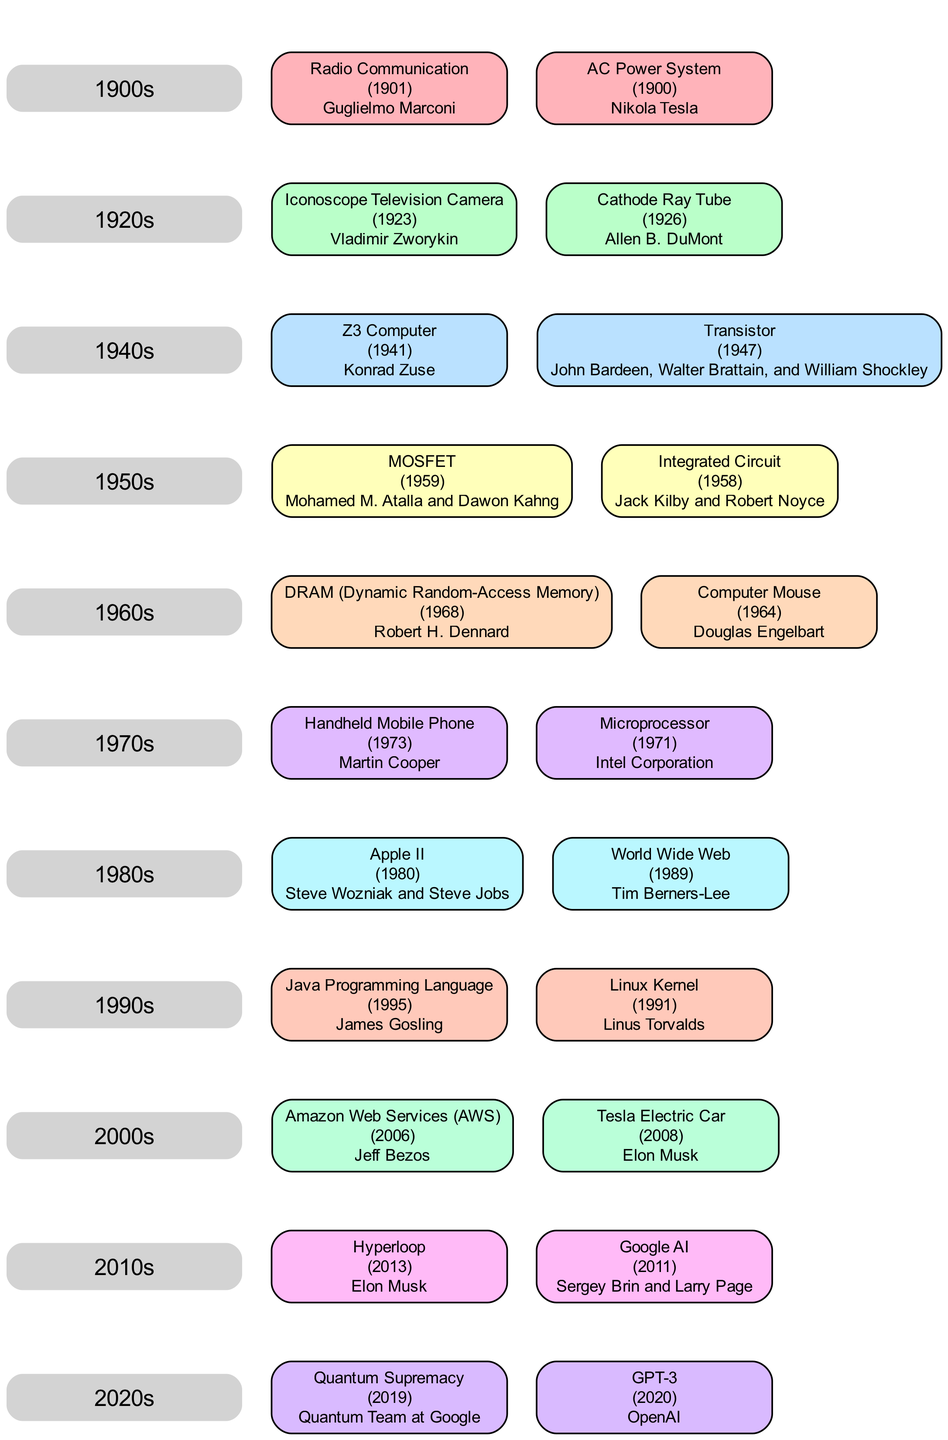What innovation did Nikola Tesla create? Nikola Tesla is listed in the "1900s" section for his innovation "AC Power System," which was developed in the year 1900. The diagram clearly labels his contribution in that decade.
Answer: AC Power System Who invented the microprocessor? The "Microprocessor" is listed under the "1970s" section with "Intel Corporation" noted as its inventor, showing a direct link from that decade to the innovation.
Answer: Intel Corporation How many innovations are listed in the 1980s? To find the total, I count the innovations listed under the "1980s" section of the diagram. There are two innovations shown: "World Wide Web" and "Apple II." Therefore, the number is two.
Answer: 2 What year did the World Wide Web become an innovation? The "World Wide Web," attributed to Tim Berners-Lee, is indicated in the "1980s" section with the specific year noted as 1989. This is clearly shown in the diagram.
Answer: 1989 Who are the inventors of the Linux Kernel? The "Linux Kernel" innovation is connected to Linus Torvalds in the "1990s" section of the diagram, and the label shows this clearly.
Answer: Linus Torvalds What is the latest innovation listed? To find the latest innovation, I look at the most recent decade in the diagram, which is the "2020s." The diagram highlights "GPT-3" under this decade, indicating it is the most recent innovation presented.
Answer: GPT-3 Which decade features the invention of the handheld mobile phone? The "Handheld Mobile Phone" invention can be found in the "1970s" section, and Martin Cooper is credited with this innovation. I can see this connection clearly in the family tree format.
Answer: 1970s What color corresponds to the 1960s innovations? Each decade is assigned a specific color in the diagram. For the "1960s," the color specified is light orange, which can be found next to the innovations listed under that decade.
Answer: #FFD9BA Which innovation came after the Z3 Computer? Looking at the connections from the "1940s" (where the Z3 Computer is listed) to the "1950s," I can see that the first innovation listed in the following decade is the "Integrated Circuit." Thus, it follows the Z3 Computer.
Answer: Integrated Circuit 